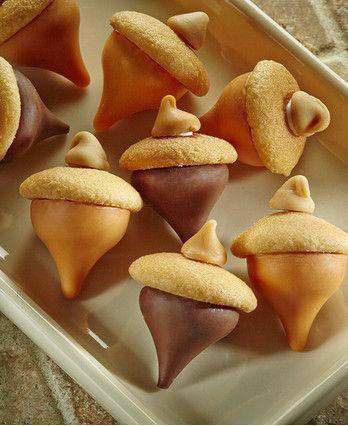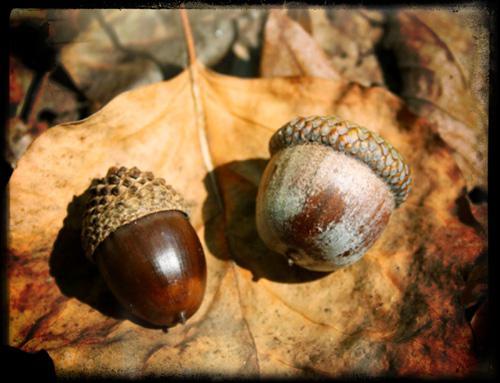The first image is the image on the left, the second image is the image on the right. Considering the images on both sides, is "One of the images is food made to look like acorns." valid? Answer yes or no. Yes. The first image is the image on the left, the second image is the image on the right. Assess this claim about the two images: "The right image shows no more than three acorns on an autumn leaf, and the left image features acorn shapes that aren't really acorns.". Correct or not? Answer yes or no. Yes. 